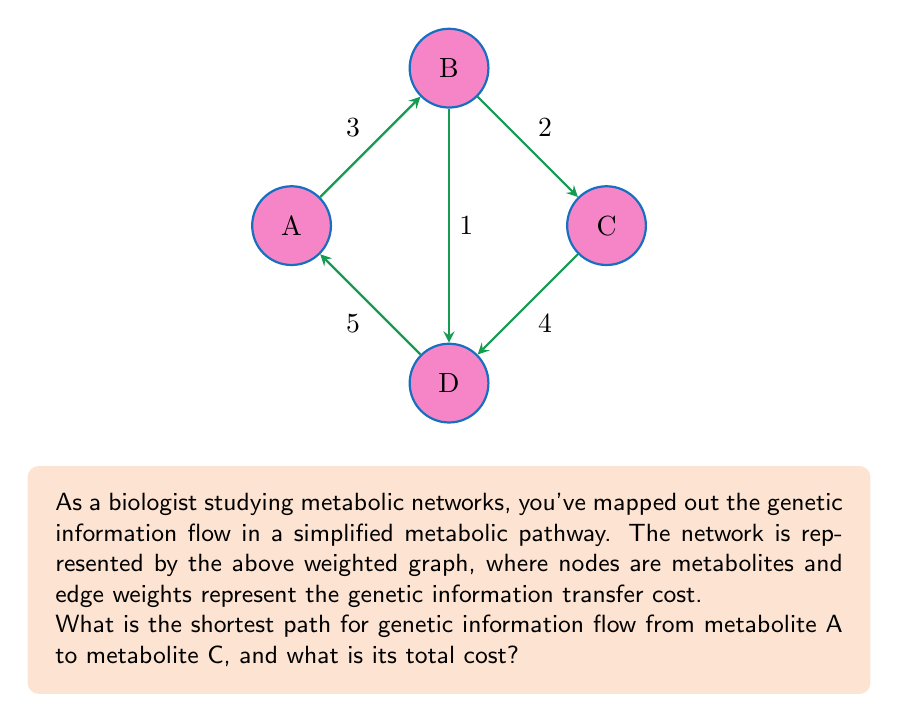Solve this math problem. To solve this problem, we need to apply Dijkstra's algorithm for finding the shortest path in a weighted graph. Let's go through the steps:

1) Initialize:
   - Distance to A: 0
   - Distance to B, C, D: $\infty$
   - Set of visited nodes: {}

2) Start from A:
   - Update distances: B(3), D(5)
   - Visited nodes: {A}

3) Choose the node with minimum distance (B):
   - Update distances: C(3+2=5)
   - Visited nodes: {A, B}

4) Choose the node with minimum distance (D):
   - Update distances: C(min(5, 5+4)=5)
   - Visited nodes: {A, B, D}

5) Choose the node with minimum distance (C):
   - All nodes visited

The shortest path from A to C is A -> B -> C with a total cost of 5.

Note: The path A -> D -> C would also have a cost of 5+4=9, which is longer.
Answer: A -> B -> C, cost = 5 